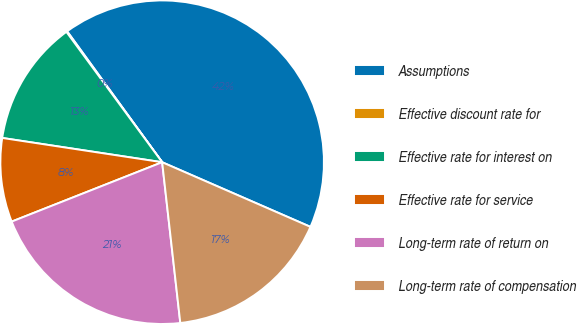Convert chart. <chart><loc_0><loc_0><loc_500><loc_500><pie_chart><fcel>Assumptions<fcel>Effective discount rate for<fcel>Effective rate for interest on<fcel>Effective rate for service<fcel>Long-term rate of return on<fcel>Long-term rate of compensation<nl><fcel>41.54%<fcel>0.09%<fcel>12.52%<fcel>8.38%<fcel>20.81%<fcel>16.67%<nl></chart> 